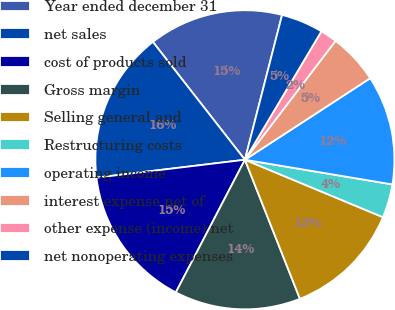<chart> <loc_0><loc_0><loc_500><loc_500><pie_chart><fcel>Year ended december 31<fcel>net sales<fcel>cost of products sold<fcel>Gross margin<fcel>Selling general and<fcel>Restructuring costs<fcel>operating income<fcel>interest expense net of<fcel>other expense (income) net<fcel>net nonoperating expenses<nl><fcel>14.55%<fcel>16.36%<fcel>15.45%<fcel>13.64%<fcel>12.73%<fcel>3.64%<fcel>11.82%<fcel>5.45%<fcel>1.82%<fcel>4.55%<nl></chart> 